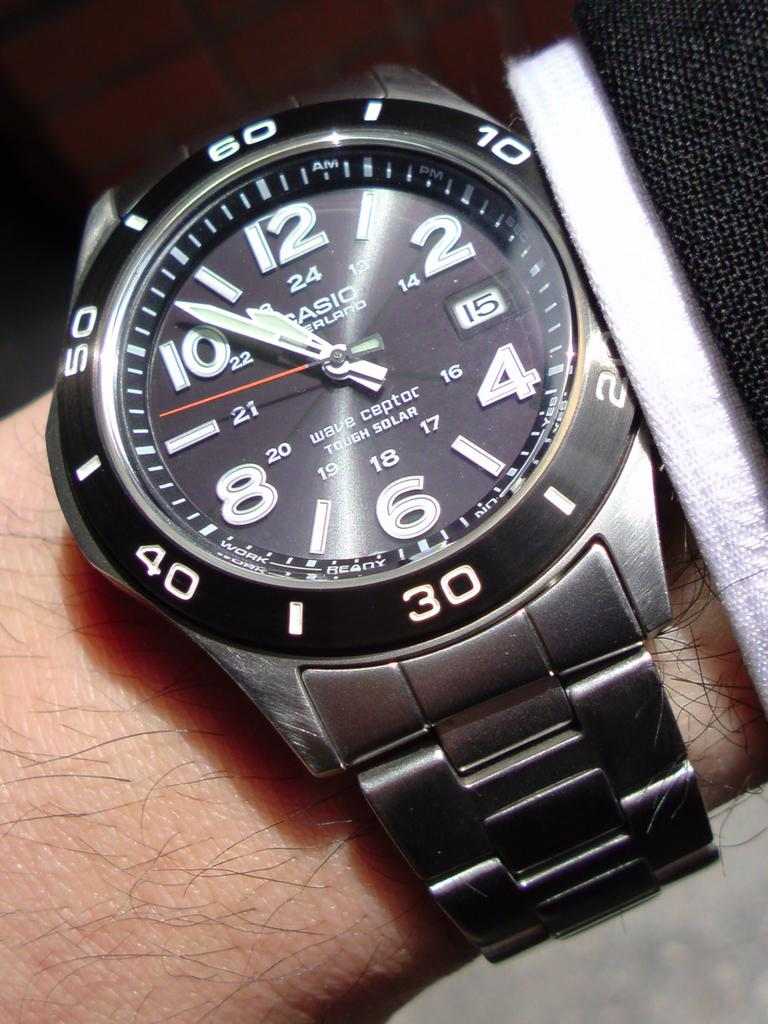<image>
Create a compact narrative representing the image presented. A Casio watch has a black face and large numbers. 